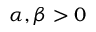<formula> <loc_0><loc_0><loc_500><loc_500>\alpha , \beta > 0</formula> 